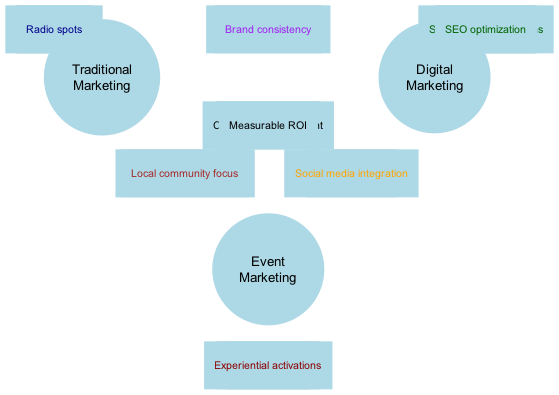What are three components found in the center overlap of the diagram? The center overlap of the Venn diagram includes "Brand awareness," "Customer engagement," and "Measurable ROI." The question directly asks for components located in the central area where all three marketing strategies intersect.
Answer: Brand awareness, Customer engagement, Measurable ROI How many items are listed under traditional marketing? There are three items listed under traditional marketing, which are "Print ads," "TV commercials," and "Radio spots." The diagram provides a clear enumeration of items associated with traditional marketing.
Answer: 3 Which marketing strategy includes "Live streaming"? "Live streaming" is included under digital marketing and event marketing as it appears in the overlap section between these two strategies. To answer the question, we identify "Live streaming" in the overlap area in the diagram.
Answer: Digital marketing, Event marketing What is the primary focus of traditional and event marketing overlap? The primary focus of the overlap between traditional and event marketing is "Face-to-face interactions" and "Local community focus." The question seeks to identify the key characteristics that arise when these two strategies are compared.
Answer: Face-to-face interactions, Local community focus Which marketing strategy contains the item "SEO optimization"? "SEO optimization" is an item listed specifically under digital marketing. The question requires identifying a specific element and determining the marketing strategy it belongs to from the diagram.
Answer: Digital marketing What two overlapping traits are shared between traditional and digital marketing? The two overlapping traits shared between traditional and digital marketing are "Integrated campaigns" and "Brand consistency." The question asks for specific items that exist in the intersection of these two strategies in the diagram, requiring reference to the overlapping section.
Answer: Integrated campaigns, Brand consistency How many marketing strategies are illustrated in the diagram? There are three marketing strategies illustrated in the diagram: traditional marketing, digital marketing, and event marketing. The question asks for the total count of distinct strategies represented in the diagram.
Answer: 3 Which marketing approach does "Experiential activations" belong to? "Experiential activations" belongs to event marketing. The diagram specifies which items belong to each marketing strategy, and this term is located under event marketing.
Answer: Event marketing 